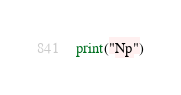<code> <loc_0><loc_0><loc_500><loc_500><_Python_>print("Np")</code> 